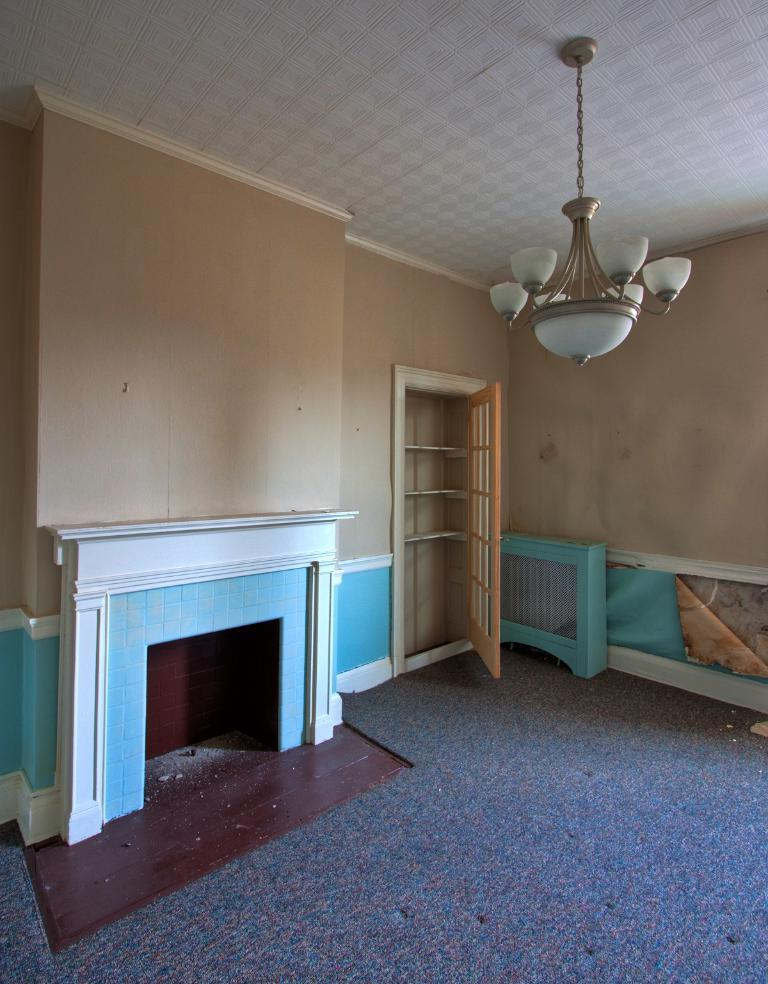What type of feature can be seen in the image? There is a fireplace in the image. What part of the room is visible in the image? The floor is visible in the image. Is there any entrance or exit in the image? Yes, there is a door in the image. What type of objects can be seen in the image? There are objects in the image. What is hanging from the ceiling in the image? There is a chandelier on the ceiling in the image. Can you see the maid cleaning the floor in the image? There is no maid present in the image. What type of machine is used to kick the ball in the image? There is no machine or ball present in the image. 